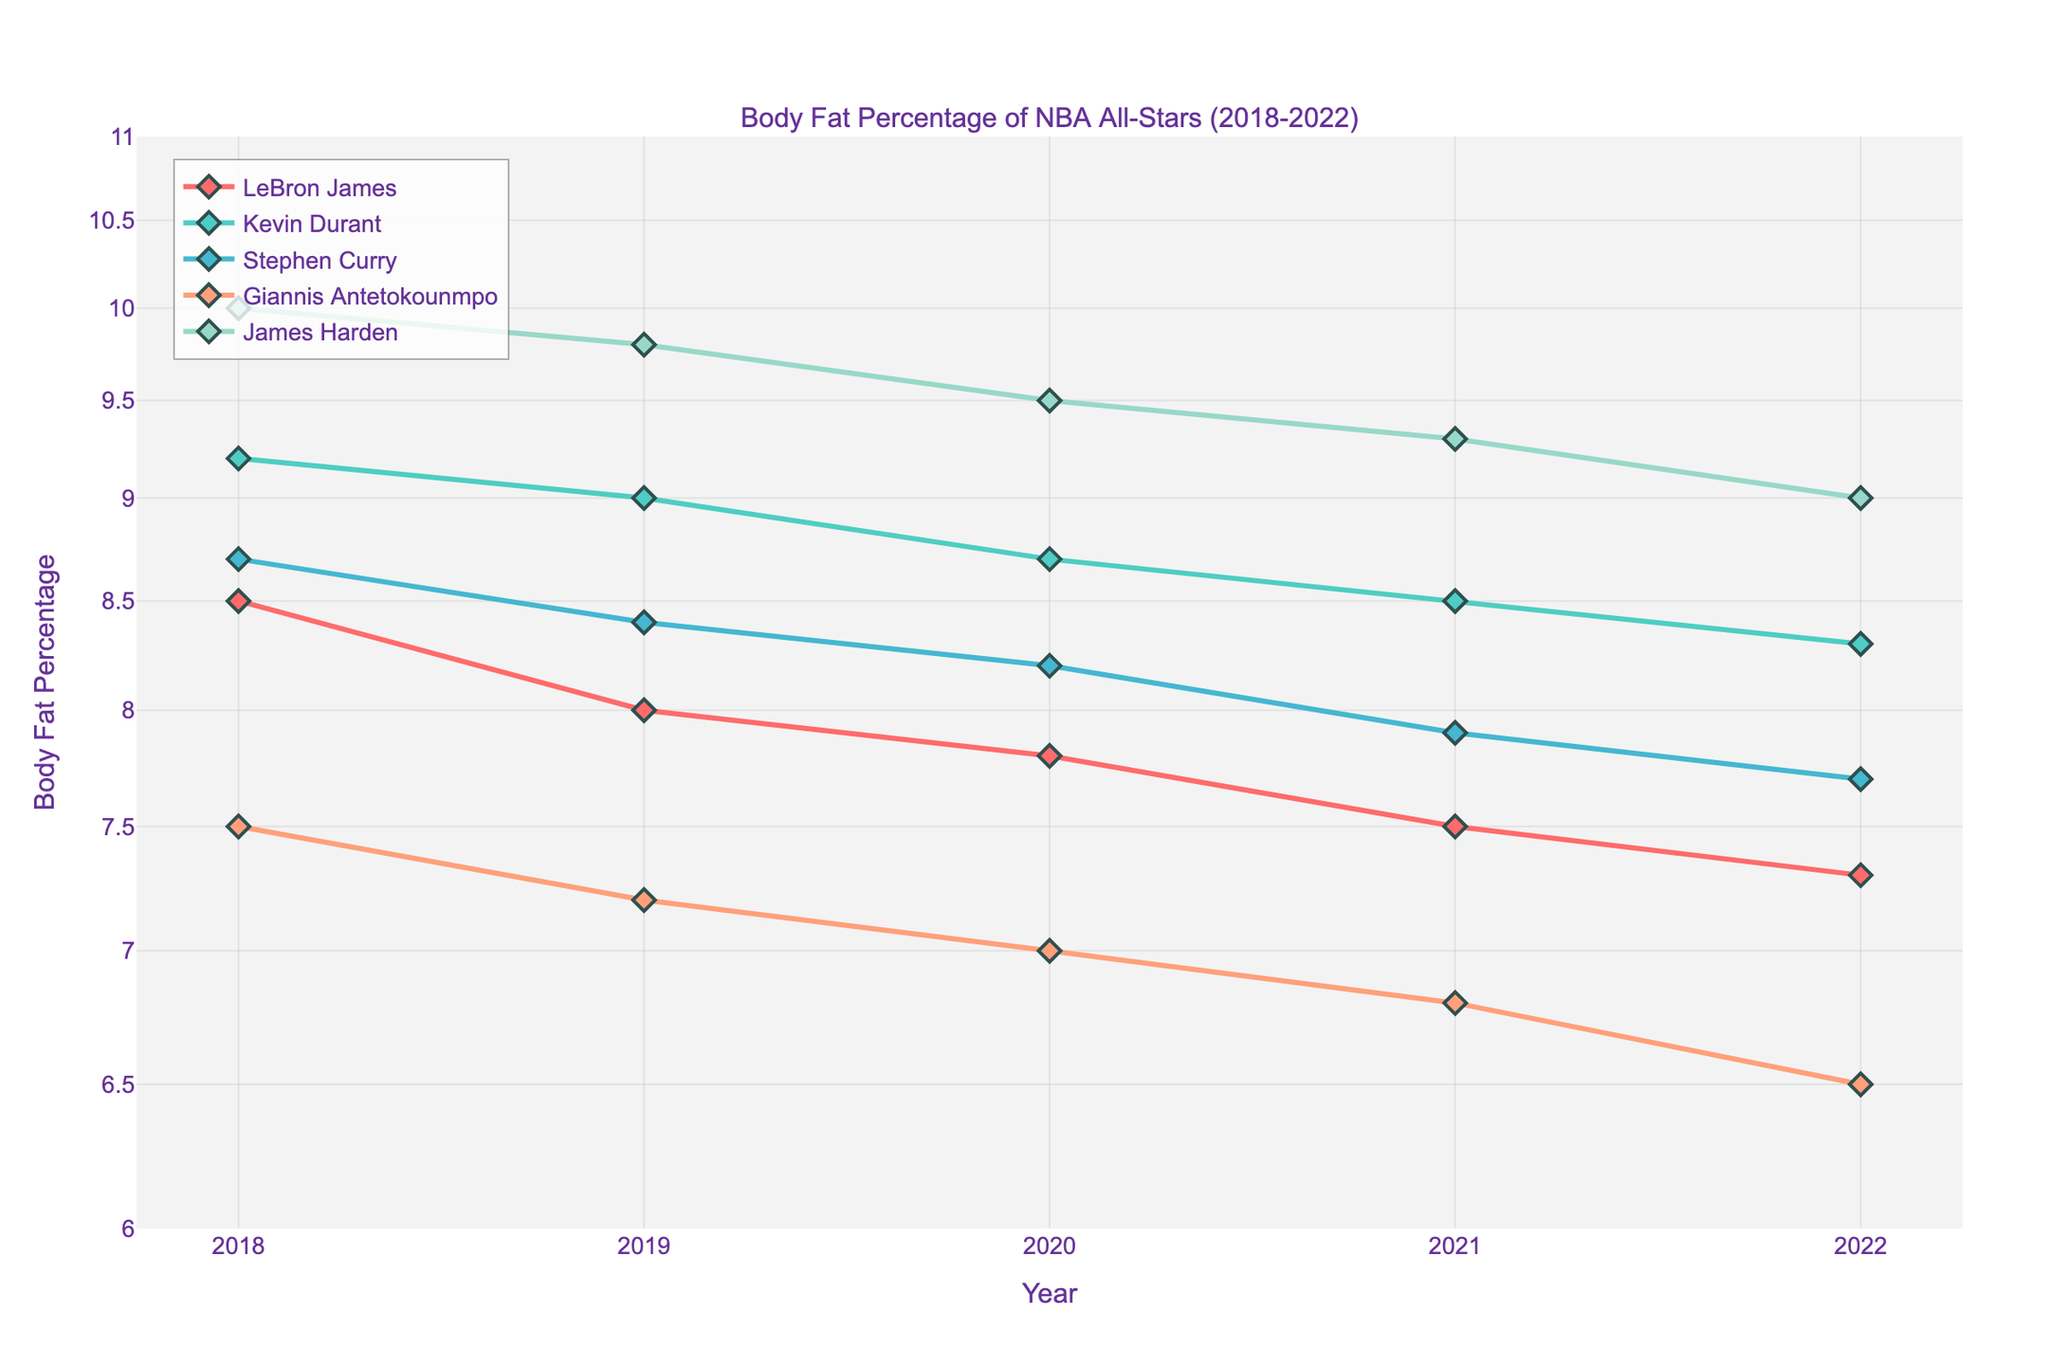How many players are represented in the plot? There are five unique lines in the plot, each representing a different player. Therefore, the plot represents five players.
Answer: 5 Which player had the lowest body fat percentage in 2018? By looking at the data points for 2018, Giannis Antetokounmpo has the lowest body fat percentage at 7.5%.
Answer: Giannis Antetokounmpo How has Kevin Durant's body fat percentage changed from 2018 to 2022? Kevin Durant's body fat percentage has decreased from 9.2% in 2018 to 8.3% in 2022. The difference is 9.2 - 8.3 = 0.9%.
Answer: Decreased by 0.9% Which player shows the most significant overall decline in body fat percentage over the 5-year period? Calculate the difference in body fat percentage for each player between 2018 and 2022:
LeBron James: 8.5 - 7.3 = 1.2%
Kevin Durant: 9.2 - 8.3 = 0.9%
Stephen Curry: 8.7 - 7.7 = 1.0%
Giannis Antetokounmpo: 7.5 - 6.5 = 1.0%
James Harden: 10.0 - 9.0 = 1.0%
LeBron James shows the most significant decline of 1.2%.
Answer: LeBron James What is the average body fat percentage of James Harden across all years? Sum James Harden’s body fat percentages from 2018 to 2022, then divide by the number of years:
(10.0 + 9.8 + 9.5 + 9.3 + 9.0) / 5 = 47.6 / 5 = 9.52%.
Answer: 9.52% What is the maximum body fat percentage recorded in 2020 and to which player does it belong? Checking the 2020 data points, the maximum body fat percentage recorded is 9.5% by James Harden.
Answer: 9.5%, James Harden Is the overall trend in body fat percentage increasing or decreasing for these players? By observing the lines for each player from 2018 to 2022, all lines show a downward trend, indicating a decreasing body fat percentage.
Answer: Decreasing Which player had a consistent decrease in body fat percentage every year from 2018 to 2022? By examining the data points for each player:
LeBron James (decrease every year)
Kevin Durant (decrease every year)
Stephen Curry (decrease every year)
Giannis Antetokounmpo (decrease every year)
James Harden (decrease every year)
All players had a consistent decrease every year, but LeBron James is the most significant.
Answer: LeBron James (and all others) How does the log scale affect the presentation of these values? The log scale compresses the range of body fat percentages, making smaller changes more visible. This representation emphasizes the relative change over time rather than absolute differences, helping to better visualize trends.
Answer: Emphasizes relative changes 